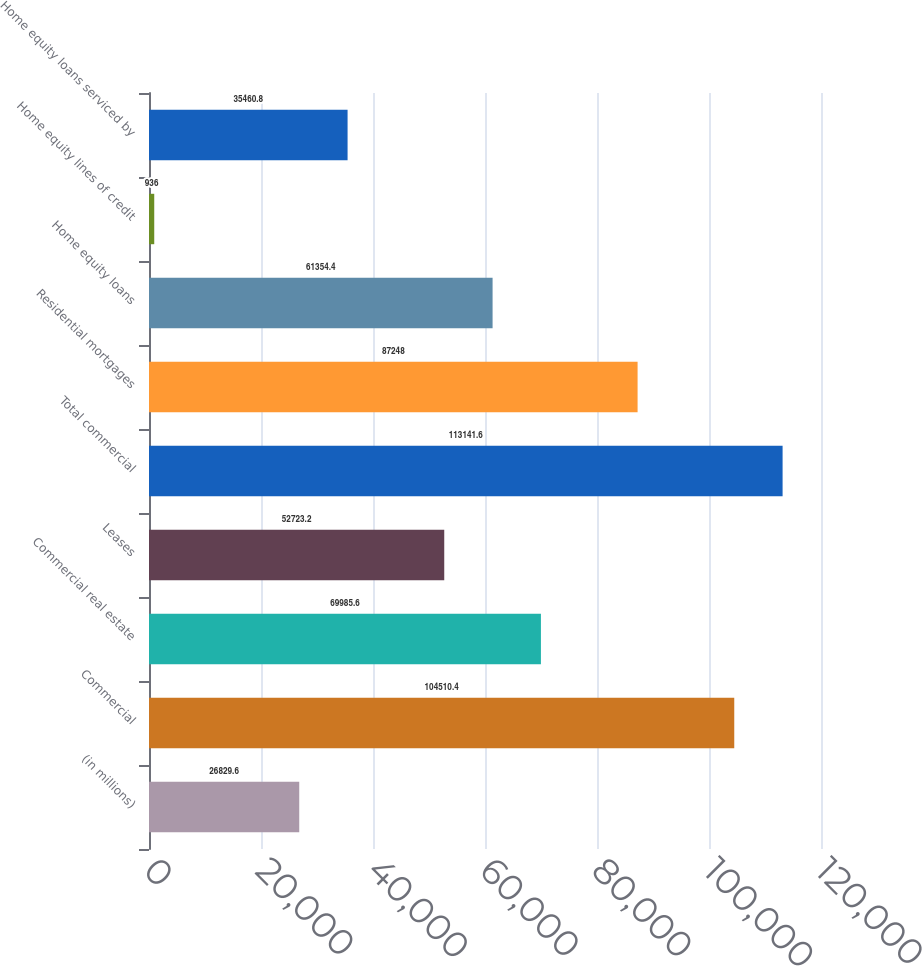Convert chart. <chart><loc_0><loc_0><loc_500><loc_500><bar_chart><fcel>(in millions)<fcel>Commercial<fcel>Commercial real estate<fcel>Leases<fcel>Total commercial<fcel>Residential mortgages<fcel>Home equity loans<fcel>Home equity lines of credit<fcel>Home equity loans serviced by<nl><fcel>26829.6<fcel>104510<fcel>69985.6<fcel>52723.2<fcel>113142<fcel>87248<fcel>61354.4<fcel>936<fcel>35460.8<nl></chart> 